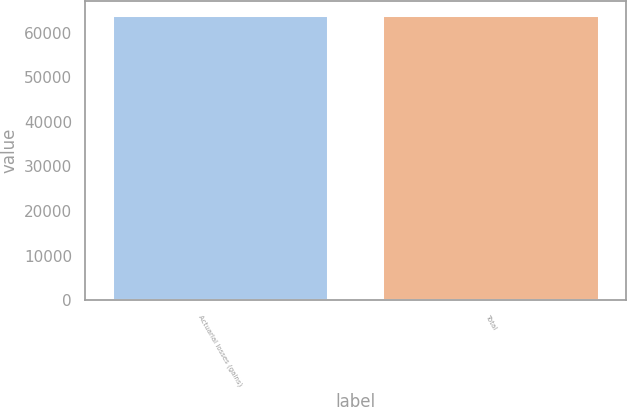Convert chart to OTSL. <chart><loc_0><loc_0><loc_500><loc_500><bar_chart><fcel>Actuarial losses (gains)<fcel>Total<nl><fcel>63958<fcel>63958.1<nl></chart> 